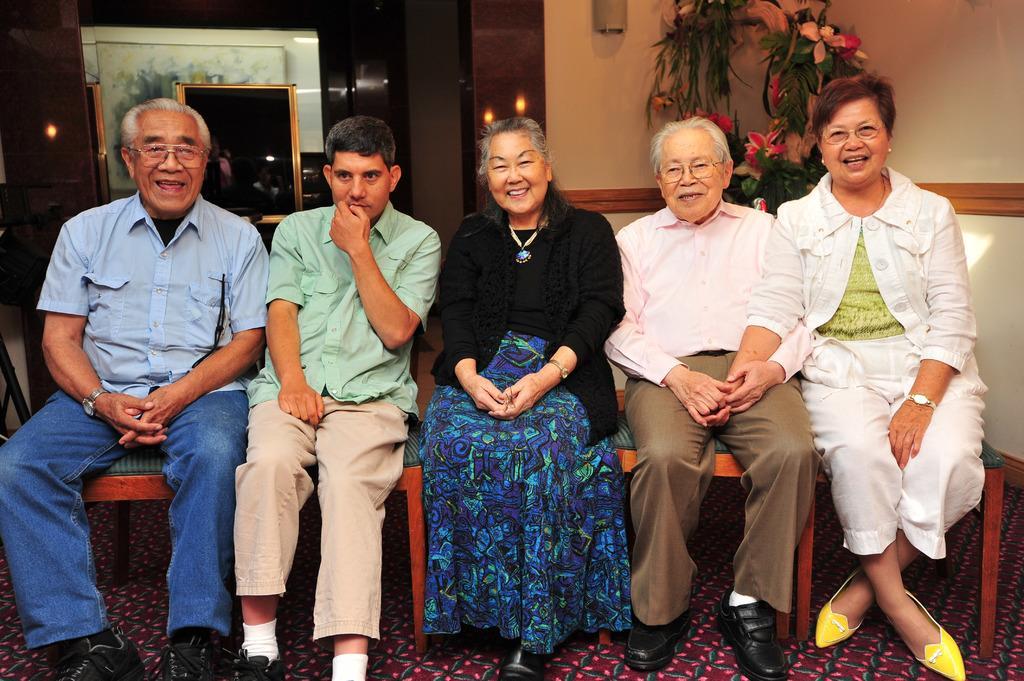Could you give a brief overview of what you see in this image? In this picture there are people those who are sitting in the center of the image and there are portraits and flowers plant in the background area of the image. 